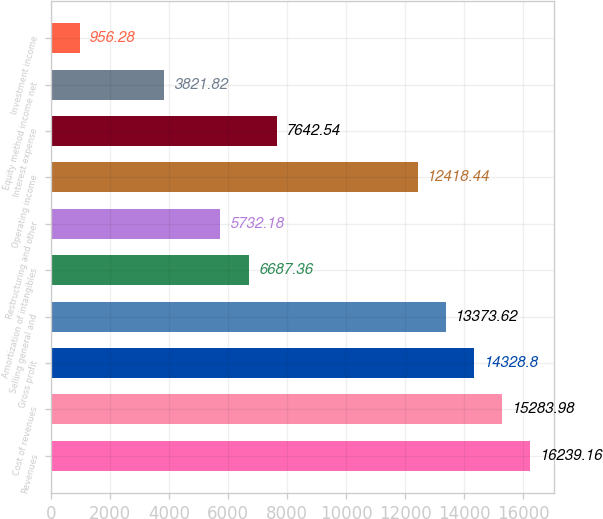Convert chart. <chart><loc_0><loc_0><loc_500><loc_500><bar_chart><fcel>Revenues<fcel>Cost of revenues<fcel>Gross profit<fcel>Selling general and<fcel>Amortization of intangibles<fcel>Restructuring and other<fcel>Operating income<fcel>Interest expense<fcel>Equity method income net<fcel>Investment income<nl><fcel>16239.2<fcel>15284<fcel>14328.8<fcel>13373.6<fcel>6687.36<fcel>5732.18<fcel>12418.4<fcel>7642.54<fcel>3821.82<fcel>956.28<nl></chart> 